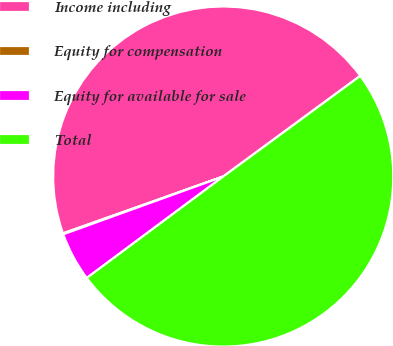Convert chart to OTSL. <chart><loc_0><loc_0><loc_500><loc_500><pie_chart><fcel>Income including<fcel>Equity for compensation<fcel>Equity for available for sale<fcel>Total<nl><fcel>45.34%<fcel>0.09%<fcel>4.66%<fcel>49.91%<nl></chart> 